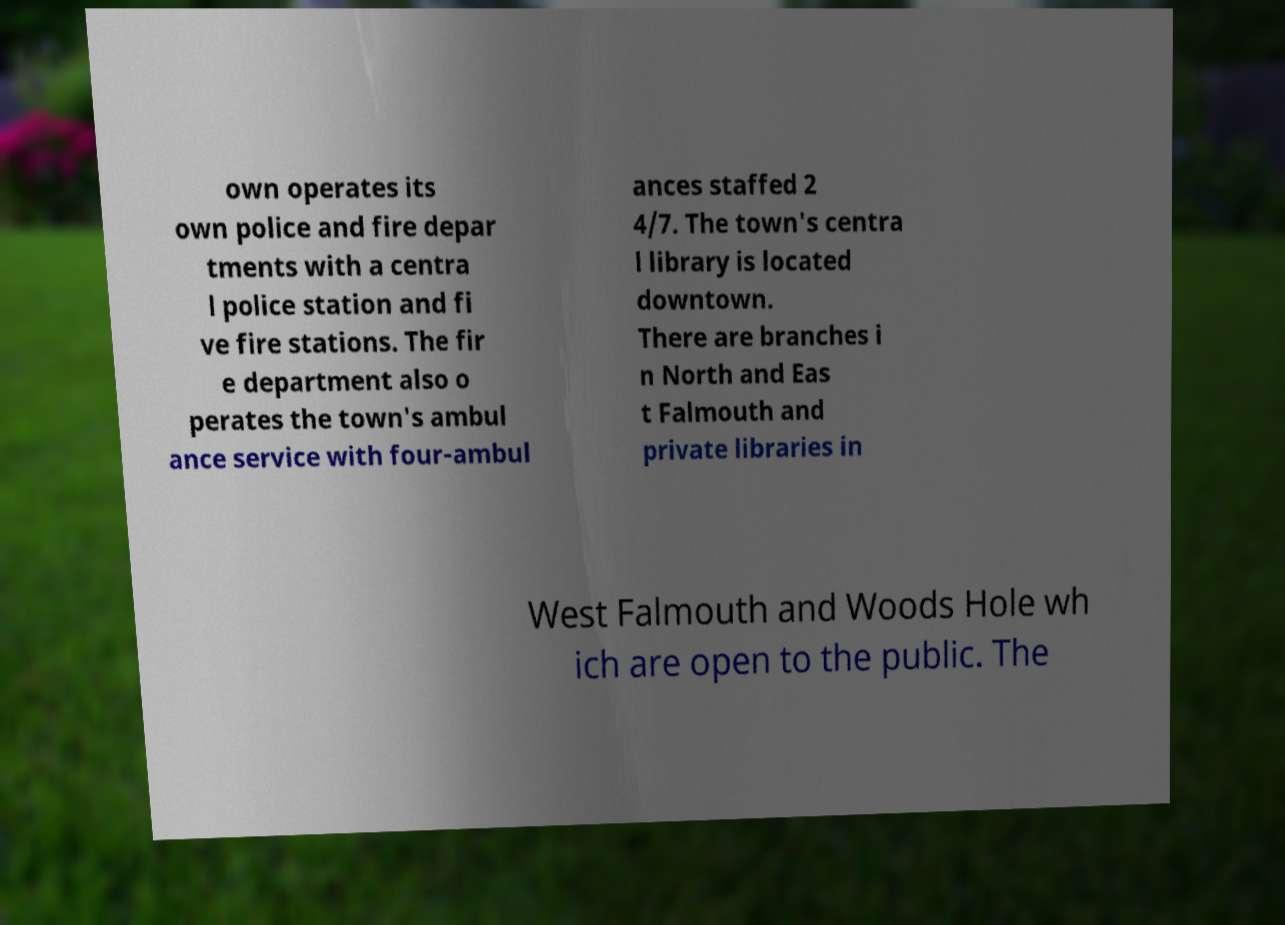There's text embedded in this image that I need extracted. Can you transcribe it verbatim? own operates its own police and fire depar tments with a centra l police station and fi ve fire stations. The fir e department also o perates the town's ambul ance service with four-ambul ances staffed 2 4/7. The town's centra l library is located downtown. There are branches i n North and Eas t Falmouth and private libraries in West Falmouth and Woods Hole wh ich are open to the public. The 